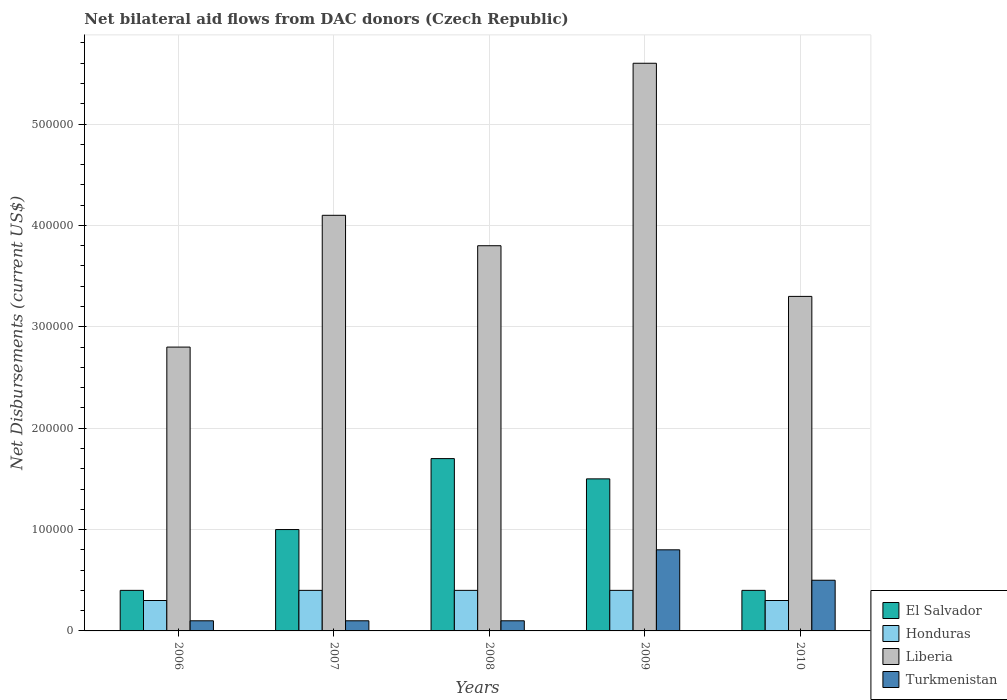How many different coloured bars are there?
Ensure brevity in your answer.  4. In how many cases, is the number of bars for a given year not equal to the number of legend labels?
Your answer should be compact. 0. What is the net bilateral aid flows in Turkmenistan in 2009?
Your answer should be very brief. 8.00e+04. Across all years, what is the maximum net bilateral aid flows in Liberia?
Your answer should be very brief. 5.60e+05. What is the total net bilateral aid flows in Honduras in the graph?
Offer a very short reply. 1.80e+05. What is the difference between the net bilateral aid flows in Honduras in 2006 and that in 2007?
Offer a terse response. -10000. In how many years, is the net bilateral aid flows in Honduras greater than 160000 US$?
Ensure brevity in your answer.  0. What is the ratio of the net bilateral aid flows in Honduras in 2007 to that in 2010?
Your response must be concise. 1.33. Is the net bilateral aid flows in Turkmenistan in 2007 less than that in 2010?
Make the answer very short. Yes. What is the difference between the highest and the lowest net bilateral aid flows in Liberia?
Provide a short and direct response. 2.80e+05. In how many years, is the net bilateral aid flows in Turkmenistan greater than the average net bilateral aid flows in Turkmenistan taken over all years?
Offer a terse response. 2. Is the sum of the net bilateral aid flows in Liberia in 2006 and 2007 greater than the maximum net bilateral aid flows in El Salvador across all years?
Make the answer very short. Yes. What does the 3rd bar from the left in 2010 represents?
Keep it short and to the point. Liberia. What does the 4th bar from the right in 2006 represents?
Your response must be concise. El Salvador. How many bars are there?
Provide a succinct answer. 20. Are all the bars in the graph horizontal?
Ensure brevity in your answer.  No. Are the values on the major ticks of Y-axis written in scientific E-notation?
Ensure brevity in your answer.  No. Does the graph contain any zero values?
Give a very brief answer. No. What is the title of the graph?
Give a very brief answer. Net bilateral aid flows from DAC donors (Czech Republic). Does "Kuwait" appear as one of the legend labels in the graph?
Offer a very short reply. No. What is the label or title of the X-axis?
Your response must be concise. Years. What is the label or title of the Y-axis?
Your response must be concise. Net Disbursements (current US$). What is the Net Disbursements (current US$) in Honduras in 2006?
Offer a terse response. 3.00e+04. What is the Net Disbursements (current US$) in Turkmenistan in 2006?
Offer a terse response. 10000. What is the Net Disbursements (current US$) in El Salvador in 2007?
Provide a succinct answer. 1.00e+05. What is the Net Disbursements (current US$) in Liberia in 2007?
Offer a very short reply. 4.10e+05. What is the Net Disbursements (current US$) in Turkmenistan in 2007?
Provide a succinct answer. 10000. What is the Net Disbursements (current US$) of El Salvador in 2008?
Your answer should be very brief. 1.70e+05. What is the Net Disbursements (current US$) in Honduras in 2008?
Offer a very short reply. 4.00e+04. What is the Net Disbursements (current US$) in Liberia in 2008?
Make the answer very short. 3.80e+05. What is the Net Disbursements (current US$) of El Salvador in 2009?
Give a very brief answer. 1.50e+05. What is the Net Disbursements (current US$) in Honduras in 2009?
Offer a very short reply. 4.00e+04. What is the Net Disbursements (current US$) in Liberia in 2009?
Give a very brief answer. 5.60e+05. What is the Net Disbursements (current US$) in Honduras in 2010?
Ensure brevity in your answer.  3.00e+04. What is the Net Disbursements (current US$) in Turkmenistan in 2010?
Offer a very short reply. 5.00e+04. Across all years, what is the maximum Net Disbursements (current US$) of El Salvador?
Keep it short and to the point. 1.70e+05. Across all years, what is the maximum Net Disbursements (current US$) in Honduras?
Keep it short and to the point. 4.00e+04. Across all years, what is the maximum Net Disbursements (current US$) in Liberia?
Provide a short and direct response. 5.60e+05. Across all years, what is the maximum Net Disbursements (current US$) in Turkmenistan?
Offer a very short reply. 8.00e+04. Across all years, what is the minimum Net Disbursements (current US$) in Liberia?
Ensure brevity in your answer.  2.80e+05. What is the total Net Disbursements (current US$) in Honduras in the graph?
Make the answer very short. 1.80e+05. What is the total Net Disbursements (current US$) in Liberia in the graph?
Offer a terse response. 1.96e+06. What is the difference between the Net Disbursements (current US$) of El Salvador in 2006 and that in 2007?
Your answer should be compact. -6.00e+04. What is the difference between the Net Disbursements (current US$) of Honduras in 2006 and that in 2007?
Keep it short and to the point. -10000. What is the difference between the Net Disbursements (current US$) of Turkmenistan in 2006 and that in 2007?
Provide a short and direct response. 0. What is the difference between the Net Disbursements (current US$) in Honduras in 2006 and that in 2008?
Your answer should be very brief. -10000. What is the difference between the Net Disbursements (current US$) of Honduras in 2006 and that in 2009?
Your answer should be compact. -10000. What is the difference between the Net Disbursements (current US$) in Liberia in 2006 and that in 2009?
Provide a succinct answer. -2.80e+05. What is the difference between the Net Disbursements (current US$) in Turkmenistan in 2006 and that in 2009?
Provide a short and direct response. -7.00e+04. What is the difference between the Net Disbursements (current US$) of El Salvador in 2006 and that in 2010?
Make the answer very short. 0. What is the difference between the Net Disbursements (current US$) in Liberia in 2006 and that in 2010?
Keep it short and to the point. -5.00e+04. What is the difference between the Net Disbursements (current US$) of Turkmenistan in 2006 and that in 2010?
Your answer should be compact. -4.00e+04. What is the difference between the Net Disbursements (current US$) of El Salvador in 2007 and that in 2008?
Make the answer very short. -7.00e+04. What is the difference between the Net Disbursements (current US$) in Honduras in 2007 and that in 2008?
Provide a succinct answer. 0. What is the difference between the Net Disbursements (current US$) of Liberia in 2007 and that in 2008?
Offer a terse response. 3.00e+04. What is the difference between the Net Disbursements (current US$) in El Salvador in 2007 and that in 2009?
Provide a succinct answer. -5.00e+04. What is the difference between the Net Disbursements (current US$) of Honduras in 2007 and that in 2010?
Your answer should be compact. 10000. What is the difference between the Net Disbursements (current US$) of Liberia in 2007 and that in 2010?
Keep it short and to the point. 8.00e+04. What is the difference between the Net Disbursements (current US$) of Turkmenistan in 2007 and that in 2010?
Provide a succinct answer. -4.00e+04. What is the difference between the Net Disbursements (current US$) of Liberia in 2008 and that in 2010?
Your answer should be compact. 5.00e+04. What is the difference between the Net Disbursements (current US$) in Liberia in 2009 and that in 2010?
Offer a terse response. 2.30e+05. What is the difference between the Net Disbursements (current US$) in El Salvador in 2006 and the Net Disbursements (current US$) in Honduras in 2007?
Your response must be concise. 0. What is the difference between the Net Disbursements (current US$) in El Salvador in 2006 and the Net Disbursements (current US$) in Liberia in 2007?
Keep it short and to the point. -3.70e+05. What is the difference between the Net Disbursements (current US$) of Honduras in 2006 and the Net Disbursements (current US$) of Liberia in 2007?
Keep it short and to the point. -3.80e+05. What is the difference between the Net Disbursements (current US$) of Honduras in 2006 and the Net Disbursements (current US$) of Turkmenistan in 2007?
Keep it short and to the point. 2.00e+04. What is the difference between the Net Disbursements (current US$) of El Salvador in 2006 and the Net Disbursements (current US$) of Honduras in 2008?
Provide a succinct answer. 0. What is the difference between the Net Disbursements (current US$) in El Salvador in 2006 and the Net Disbursements (current US$) in Liberia in 2008?
Ensure brevity in your answer.  -3.40e+05. What is the difference between the Net Disbursements (current US$) of El Salvador in 2006 and the Net Disbursements (current US$) of Turkmenistan in 2008?
Ensure brevity in your answer.  3.00e+04. What is the difference between the Net Disbursements (current US$) in Honduras in 2006 and the Net Disbursements (current US$) in Liberia in 2008?
Offer a terse response. -3.50e+05. What is the difference between the Net Disbursements (current US$) of Liberia in 2006 and the Net Disbursements (current US$) of Turkmenistan in 2008?
Provide a succinct answer. 2.70e+05. What is the difference between the Net Disbursements (current US$) of El Salvador in 2006 and the Net Disbursements (current US$) of Liberia in 2009?
Make the answer very short. -5.20e+05. What is the difference between the Net Disbursements (current US$) in Honduras in 2006 and the Net Disbursements (current US$) in Liberia in 2009?
Your response must be concise. -5.30e+05. What is the difference between the Net Disbursements (current US$) of El Salvador in 2006 and the Net Disbursements (current US$) of Liberia in 2010?
Keep it short and to the point. -2.90e+05. What is the difference between the Net Disbursements (current US$) in El Salvador in 2007 and the Net Disbursements (current US$) in Honduras in 2008?
Your answer should be compact. 6.00e+04. What is the difference between the Net Disbursements (current US$) in El Salvador in 2007 and the Net Disbursements (current US$) in Liberia in 2008?
Offer a terse response. -2.80e+05. What is the difference between the Net Disbursements (current US$) in El Salvador in 2007 and the Net Disbursements (current US$) in Turkmenistan in 2008?
Offer a terse response. 9.00e+04. What is the difference between the Net Disbursements (current US$) of Honduras in 2007 and the Net Disbursements (current US$) of Liberia in 2008?
Give a very brief answer. -3.40e+05. What is the difference between the Net Disbursements (current US$) in Honduras in 2007 and the Net Disbursements (current US$) in Turkmenistan in 2008?
Offer a terse response. 3.00e+04. What is the difference between the Net Disbursements (current US$) in Liberia in 2007 and the Net Disbursements (current US$) in Turkmenistan in 2008?
Ensure brevity in your answer.  4.00e+05. What is the difference between the Net Disbursements (current US$) of El Salvador in 2007 and the Net Disbursements (current US$) of Liberia in 2009?
Offer a terse response. -4.60e+05. What is the difference between the Net Disbursements (current US$) in Honduras in 2007 and the Net Disbursements (current US$) in Liberia in 2009?
Make the answer very short. -5.20e+05. What is the difference between the Net Disbursements (current US$) of El Salvador in 2007 and the Net Disbursements (current US$) of Turkmenistan in 2010?
Ensure brevity in your answer.  5.00e+04. What is the difference between the Net Disbursements (current US$) in Honduras in 2007 and the Net Disbursements (current US$) in Liberia in 2010?
Your answer should be compact. -2.90e+05. What is the difference between the Net Disbursements (current US$) of Honduras in 2007 and the Net Disbursements (current US$) of Turkmenistan in 2010?
Provide a short and direct response. -10000. What is the difference between the Net Disbursements (current US$) of Liberia in 2007 and the Net Disbursements (current US$) of Turkmenistan in 2010?
Provide a succinct answer. 3.60e+05. What is the difference between the Net Disbursements (current US$) of El Salvador in 2008 and the Net Disbursements (current US$) of Honduras in 2009?
Your answer should be compact. 1.30e+05. What is the difference between the Net Disbursements (current US$) in El Salvador in 2008 and the Net Disbursements (current US$) in Liberia in 2009?
Make the answer very short. -3.90e+05. What is the difference between the Net Disbursements (current US$) of El Salvador in 2008 and the Net Disbursements (current US$) of Turkmenistan in 2009?
Give a very brief answer. 9.00e+04. What is the difference between the Net Disbursements (current US$) of Honduras in 2008 and the Net Disbursements (current US$) of Liberia in 2009?
Keep it short and to the point. -5.20e+05. What is the difference between the Net Disbursements (current US$) in El Salvador in 2008 and the Net Disbursements (current US$) in Honduras in 2010?
Your response must be concise. 1.40e+05. What is the difference between the Net Disbursements (current US$) of El Salvador in 2008 and the Net Disbursements (current US$) of Liberia in 2010?
Provide a short and direct response. -1.60e+05. What is the difference between the Net Disbursements (current US$) in El Salvador in 2009 and the Net Disbursements (current US$) in Honduras in 2010?
Provide a short and direct response. 1.20e+05. What is the difference between the Net Disbursements (current US$) of Honduras in 2009 and the Net Disbursements (current US$) of Liberia in 2010?
Your answer should be compact. -2.90e+05. What is the difference between the Net Disbursements (current US$) in Liberia in 2009 and the Net Disbursements (current US$) in Turkmenistan in 2010?
Ensure brevity in your answer.  5.10e+05. What is the average Net Disbursements (current US$) of Honduras per year?
Your answer should be compact. 3.60e+04. What is the average Net Disbursements (current US$) of Liberia per year?
Make the answer very short. 3.92e+05. What is the average Net Disbursements (current US$) of Turkmenistan per year?
Provide a short and direct response. 3.20e+04. In the year 2006, what is the difference between the Net Disbursements (current US$) in El Salvador and Net Disbursements (current US$) in Turkmenistan?
Provide a succinct answer. 3.00e+04. In the year 2007, what is the difference between the Net Disbursements (current US$) of El Salvador and Net Disbursements (current US$) of Liberia?
Give a very brief answer. -3.10e+05. In the year 2007, what is the difference between the Net Disbursements (current US$) in Honduras and Net Disbursements (current US$) in Liberia?
Provide a short and direct response. -3.70e+05. In the year 2008, what is the difference between the Net Disbursements (current US$) in El Salvador and Net Disbursements (current US$) in Honduras?
Your answer should be compact. 1.30e+05. In the year 2008, what is the difference between the Net Disbursements (current US$) of El Salvador and Net Disbursements (current US$) of Liberia?
Make the answer very short. -2.10e+05. In the year 2008, what is the difference between the Net Disbursements (current US$) in Honduras and Net Disbursements (current US$) in Turkmenistan?
Your response must be concise. 3.00e+04. In the year 2009, what is the difference between the Net Disbursements (current US$) in El Salvador and Net Disbursements (current US$) in Honduras?
Offer a terse response. 1.10e+05. In the year 2009, what is the difference between the Net Disbursements (current US$) in El Salvador and Net Disbursements (current US$) in Liberia?
Provide a short and direct response. -4.10e+05. In the year 2009, what is the difference between the Net Disbursements (current US$) in El Salvador and Net Disbursements (current US$) in Turkmenistan?
Ensure brevity in your answer.  7.00e+04. In the year 2009, what is the difference between the Net Disbursements (current US$) in Honduras and Net Disbursements (current US$) in Liberia?
Provide a succinct answer. -5.20e+05. In the year 2009, what is the difference between the Net Disbursements (current US$) in Liberia and Net Disbursements (current US$) in Turkmenistan?
Offer a terse response. 4.80e+05. In the year 2010, what is the difference between the Net Disbursements (current US$) in El Salvador and Net Disbursements (current US$) in Honduras?
Offer a very short reply. 10000. In the year 2010, what is the difference between the Net Disbursements (current US$) of El Salvador and Net Disbursements (current US$) of Liberia?
Give a very brief answer. -2.90e+05. In the year 2010, what is the difference between the Net Disbursements (current US$) in El Salvador and Net Disbursements (current US$) in Turkmenistan?
Offer a terse response. -10000. In the year 2010, what is the difference between the Net Disbursements (current US$) of Liberia and Net Disbursements (current US$) of Turkmenistan?
Make the answer very short. 2.80e+05. What is the ratio of the Net Disbursements (current US$) of El Salvador in 2006 to that in 2007?
Keep it short and to the point. 0.4. What is the ratio of the Net Disbursements (current US$) in Liberia in 2006 to that in 2007?
Provide a short and direct response. 0.68. What is the ratio of the Net Disbursements (current US$) in El Salvador in 2006 to that in 2008?
Give a very brief answer. 0.24. What is the ratio of the Net Disbursements (current US$) in Honduras in 2006 to that in 2008?
Your answer should be compact. 0.75. What is the ratio of the Net Disbursements (current US$) of Liberia in 2006 to that in 2008?
Offer a very short reply. 0.74. What is the ratio of the Net Disbursements (current US$) in Turkmenistan in 2006 to that in 2008?
Provide a short and direct response. 1. What is the ratio of the Net Disbursements (current US$) in El Salvador in 2006 to that in 2009?
Ensure brevity in your answer.  0.27. What is the ratio of the Net Disbursements (current US$) in Honduras in 2006 to that in 2009?
Offer a terse response. 0.75. What is the ratio of the Net Disbursements (current US$) in Liberia in 2006 to that in 2009?
Your response must be concise. 0.5. What is the ratio of the Net Disbursements (current US$) of Turkmenistan in 2006 to that in 2009?
Ensure brevity in your answer.  0.12. What is the ratio of the Net Disbursements (current US$) of Honduras in 2006 to that in 2010?
Keep it short and to the point. 1. What is the ratio of the Net Disbursements (current US$) in Liberia in 2006 to that in 2010?
Provide a succinct answer. 0.85. What is the ratio of the Net Disbursements (current US$) of El Salvador in 2007 to that in 2008?
Your answer should be compact. 0.59. What is the ratio of the Net Disbursements (current US$) in Liberia in 2007 to that in 2008?
Keep it short and to the point. 1.08. What is the ratio of the Net Disbursements (current US$) of Turkmenistan in 2007 to that in 2008?
Offer a very short reply. 1. What is the ratio of the Net Disbursements (current US$) in El Salvador in 2007 to that in 2009?
Your response must be concise. 0.67. What is the ratio of the Net Disbursements (current US$) in Honduras in 2007 to that in 2009?
Your answer should be compact. 1. What is the ratio of the Net Disbursements (current US$) of Liberia in 2007 to that in 2009?
Your answer should be very brief. 0.73. What is the ratio of the Net Disbursements (current US$) of Liberia in 2007 to that in 2010?
Make the answer very short. 1.24. What is the ratio of the Net Disbursements (current US$) of El Salvador in 2008 to that in 2009?
Ensure brevity in your answer.  1.13. What is the ratio of the Net Disbursements (current US$) of Liberia in 2008 to that in 2009?
Offer a very short reply. 0.68. What is the ratio of the Net Disbursements (current US$) in El Salvador in 2008 to that in 2010?
Give a very brief answer. 4.25. What is the ratio of the Net Disbursements (current US$) of Liberia in 2008 to that in 2010?
Your answer should be compact. 1.15. What is the ratio of the Net Disbursements (current US$) in El Salvador in 2009 to that in 2010?
Offer a very short reply. 3.75. What is the ratio of the Net Disbursements (current US$) of Liberia in 2009 to that in 2010?
Ensure brevity in your answer.  1.7. What is the difference between the highest and the second highest Net Disbursements (current US$) in Liberia?
Your answer should be compact. 1.50e+05. What is the difference between the highest and the lowest Net Disbursements (current US$) in El Salvador?
Offer a very short reply. 1.30e+05. What is the difference between the highest and the lowest Net Disbursements (current US$) of Liberia?
Ensure brevity in your answer.  2.80e+05. 